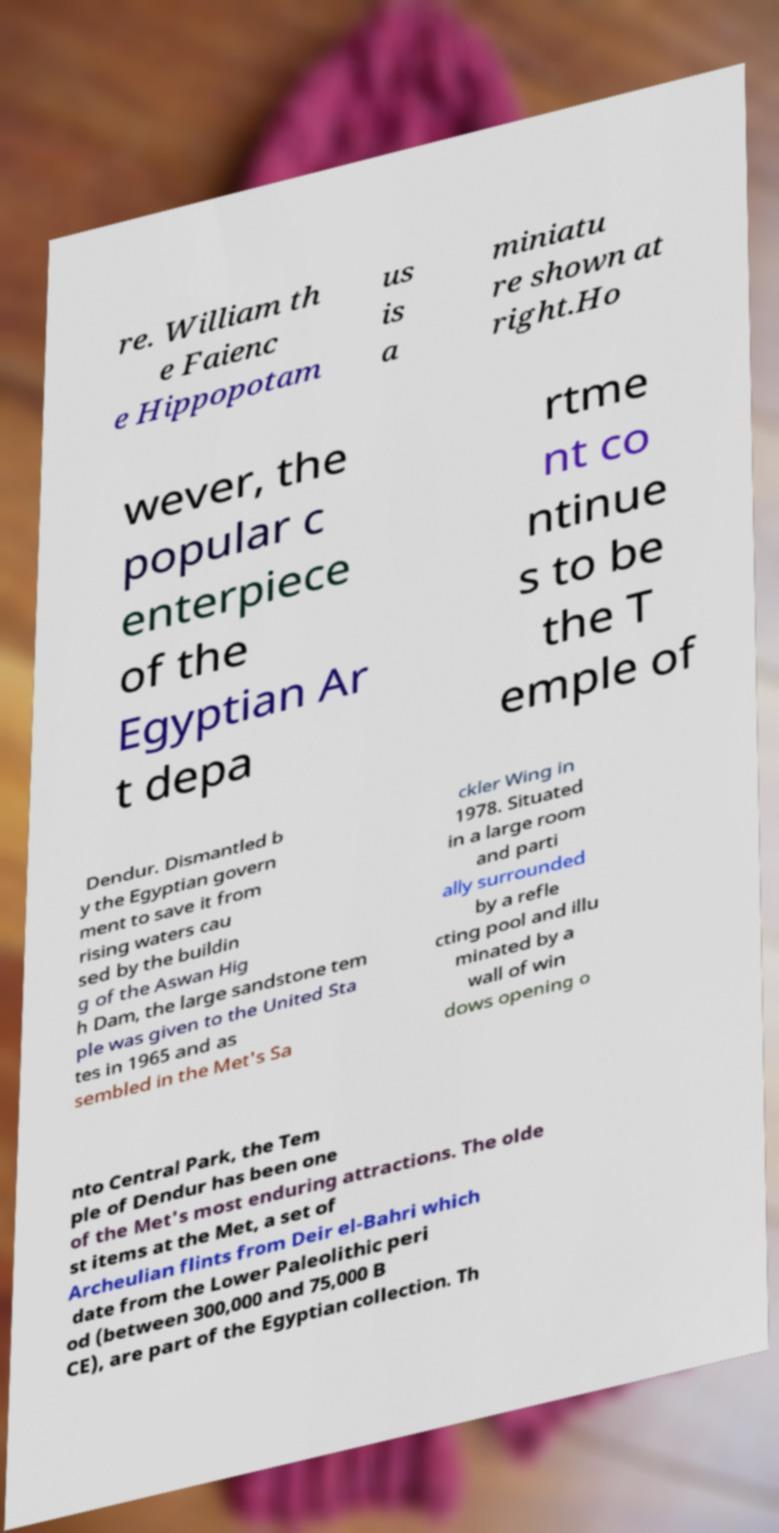Please read and relay the text visible in this image. What does it say? re. William th e Faienc e Hippopotam us is a miniatu re shown at right.Ho wever, the popular c enterpiece of the Egyptian Ar t depa rtme nt co ntinue s to be the T emple of Dendur. Dismantled b y the Egyptian govern ment to save it from rising waters cau sed by the buildin g of the Aswan Hig h Dam, the large sandstone tem ple was given to the United Sta tes in 1965 and as sembled in the Met's Sa ckler Wing in 1978. Situated in a large room and parti ally surrounded by a refle cting pool and illu minated by a wall of win dows opening o nto Central Park, the Tem ple of Dendur has been one of the Met's most enduring attractions. The olde st items at the Met, a set of Archeulian flints from Deir el-Bahri which date from the Lower Paleolithic peri od (between 300,000 and 75,000 B CE), are part of the Egyptian collection. Th 